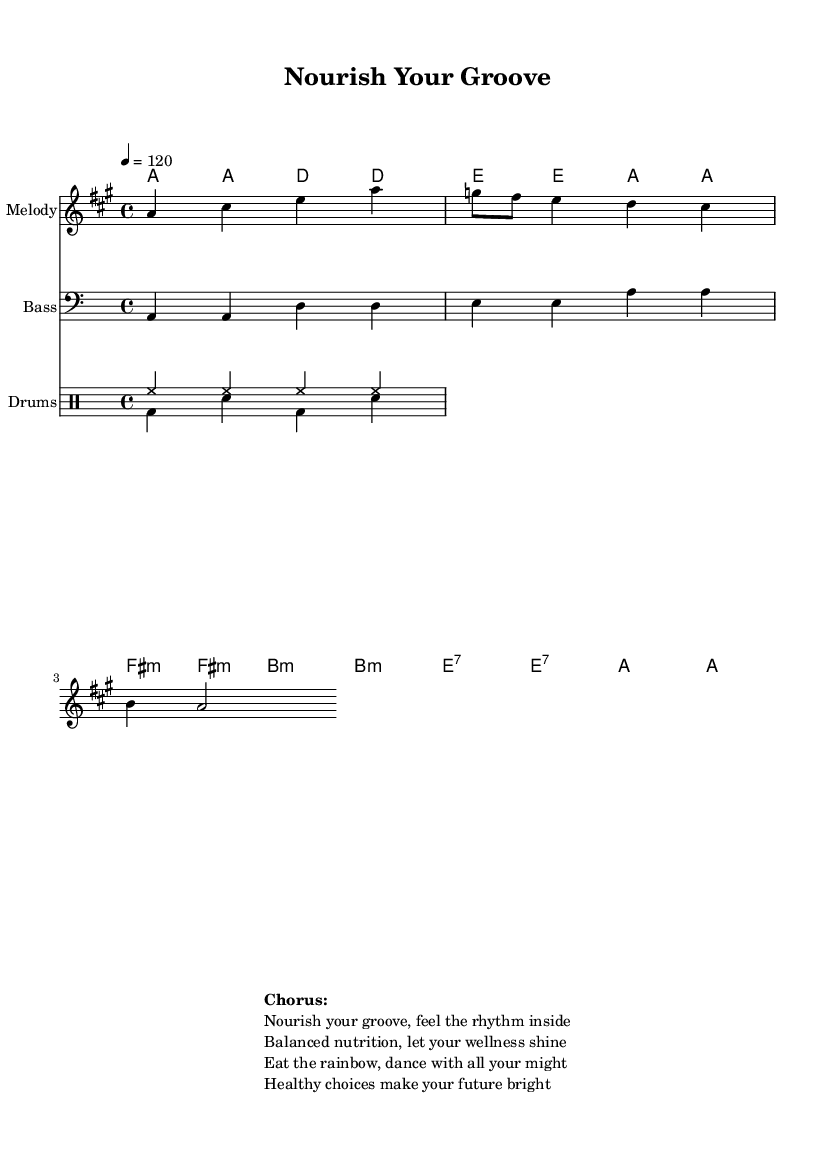What is the key signature of this music? The key signature is A major, indicated by three sharps (F#, C#, and G#). You can determine this by looking at the beginning of the staff where the sharps are notated.
Answer: A major What is the time signature of this piece? The time signature is 4/4, which means there are four beats per measure and the quarter note gets one beat. You can identify this at the beginning of the score where the time signature is written.
Answer: 4/4 What is the tempo marking for this music? The tempo marking is quarter note equals 120 beats per minute, indicated by "4 = 120." This tells performers how fast the piece should be played.
Answer: 120 What type of rhythm pattern is used for the drums? The drum pattern consists of a hi-hat pattern played consistently and a bass-drum/snare pattern which alternates, as shown in the drum dimensions positioned around the staff. This combination creates a lively Disco feel.
Answer: Hi-hat and bass-snare pattern What is the main theme of the chorus? The main theme encourages balanced nutrition and wellness, suggesting to "Eat the rainbow" and "healthy choices make your future bright." This message is typical in Disco anthems that promote joy and positivity through healthy living.
Answer: Nutritional wellness How many measures are there in the melody? There are eight measures in the melody part, evident from the division of the melody line into segments that align with the harmony and rhythm structure to create a coherent flow.
Answer: 8 measures What chord is played throughout the majority of the music? The chord played throughout the majority of the music is A major. In the chord progression, you can see that the A major chord features predominantly, indicating it as the tonic or home chord in this key.
Answer: A major 